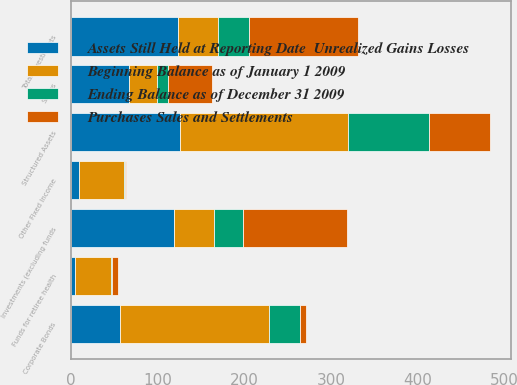Convert chart. <chart><loc_0><loc_0><loc_500><loc_500><stacked_bar_chart><ecel><fcel>Corporate Bonds<fcel>Structured Assets<fcel>Other Fixed Income<fcel>Swaps<fcel>Total investments<fcel>Funds for retiree health<fcel>Investments (excluding funds<nl><fcel>Beginning Balance as of January 1 2009<fcel>172<fcel>194<fcel>52<fcel>32<fcel>46<fcel>41<fcel>46<nl><fcel>Ending Balance as of December 31 2009<fcel>35<fcel>93<fcel>2<fcel>13<fcel>36<fcel>2<fcel>34<nl><fcel>Purchases Sales and Settlements<fcel>7<fcel>70<fcel>1<fcel>51<fcel>125<fcel>6<fcel>119<nl><fcel>Assets Still Held at Reporting Date  Unrealized Gains Losses<fcel>57<fcel>126<fcel>9<fcel>67<fcel>124<fcel>5<fcel>119<nl></chart> 